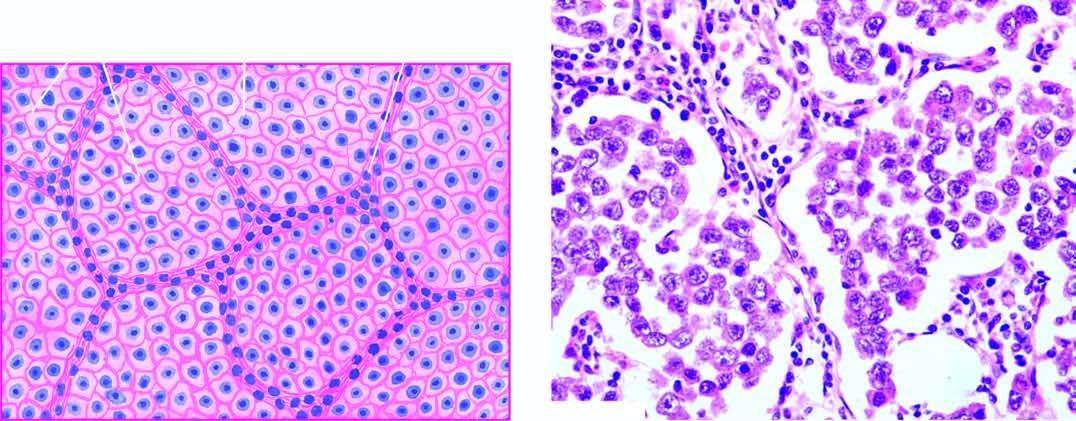what does microscopy of the tumour show?
Answer the question using a single word or phrase. Lobules of monomorphic seminoma cells 